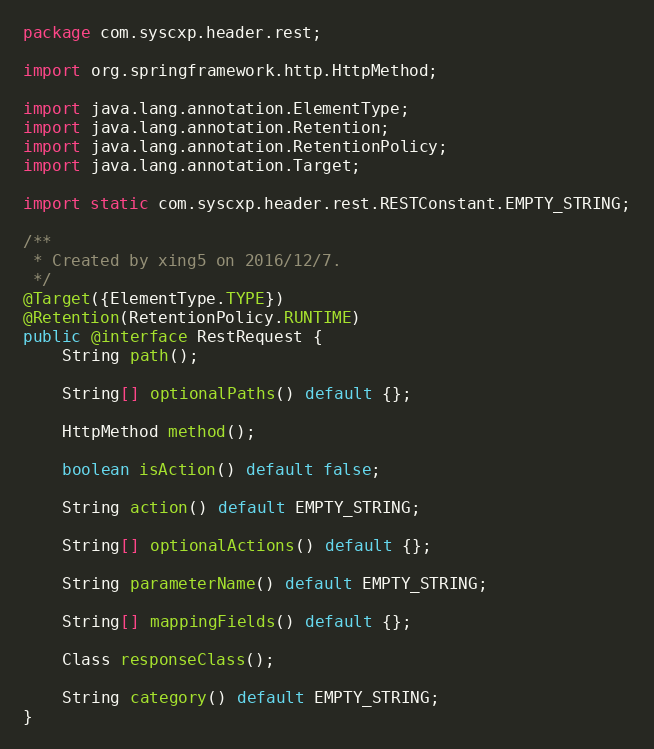<code> <loc_0><loc_0><loc_500><loc_500><_Java_>package com.syscxp.header.rest;

import org.springframework.http.HttpMethod;

import java.lang.annotation.ElementType;
import java.lang.annotation.Retention;
import java.lang.annotation.RetentionPolicy;
import java.lang.annotation.Target;

import static com.syscxp.header.rest.RESTConstant.EMPTY_STRING;

/**
 * Created by xing5 on 2016/12/7.
 */
@Target({ElementType.TYPE})
@Retention(RetentionPolicy.RUNTIME)
public @interface RestRequest {
    String path();

    String[] optionalPaths() default {};

    HttpMethod method();

    boolean isAction() default false;

    String action() default EMPTY_STRING;

    String[] optionalActions() default {};

    String parameterName() default EMPTY_STRING;

    String[] mappingFields() default {};

    Class responseClass();

    String category() default EMPTY_STRING;
}
</code> 